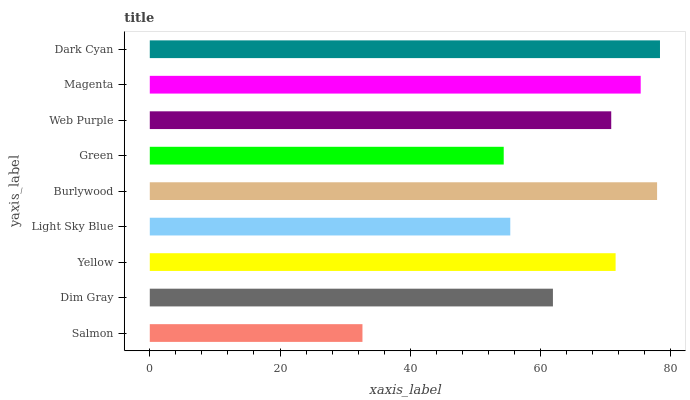Is Salmon the minimum?
Answer yes or no. Yes. Is Dark Cyan the maximum?
Answer yes or no. Yes. Is Dim Gray the minimum?
Answer yes or no. No. Is Dim Gray the maximum?
Answer yes or no. No. Is Dim Gray greater than Salmon?
Answer yes or no. Yes. Is Salmon less than Dim Gray?
Answer yes or no. Yes. Is Salmon greater than Dim Gray?
Answer yes or no. No. Is Dim Gray less than Salmon?
Answer yes or no. No. Is Web Purple the high median?
Answer yes or no. Yes. Is Web Purple the low median?
Answer yes or no. Yes. Is Light Sky Blue the high median?
Answer yes or no. No. Is Dark Cyan the low median?
Answer yes or no. No. 